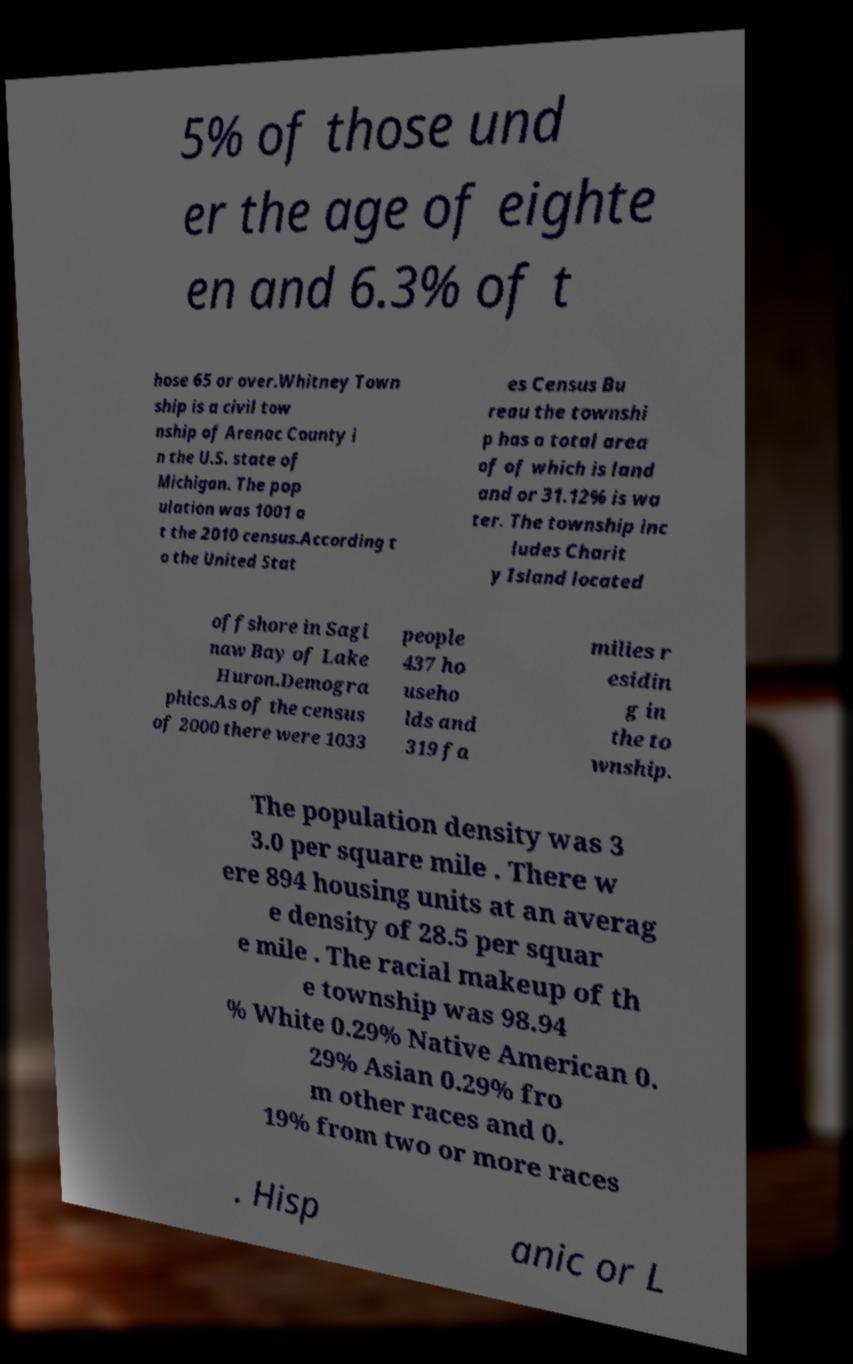There's text embedded in this image that I need extracted. Can you transcribe it verbatim? 5% of those und er the age of eighte en and 6.3% of t hose 65 or over.Whitney Town ship is a civil tow nship of Arenac County i n the U.S. state of Michigan. The pop ulation was 1001 a t the 2010 census.According t o the United Stat es Census Bu reau the townshi p has a total area of of which is land and or 31.12% is wa ter. The township inc ludes Charit y Island located offshore in Sagi naw Bay of Lake Huron.Demogra phics.As of the census of 2000 there were 1033 people 437 ho useho lds and 319 fa milies r esidin g in the to wnship. The population density was 3 3.0 per square mile . There w ere 894 housing units at an averag e density of 28.5 per squar e mile . The racial makeup of th e township was 98.94 % White 0.29% Native American 0. 29% Asian 0.29% fro m other races and 0. 19% from two or more races . Hisp anic or L 